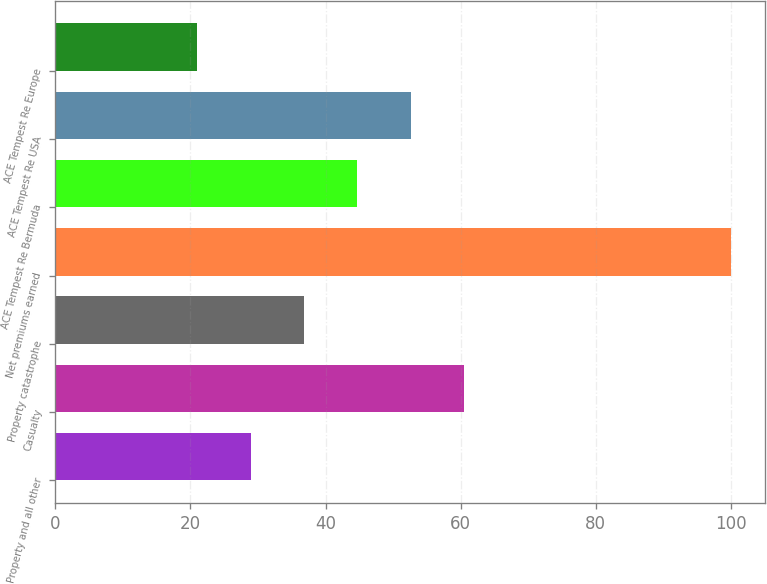<chart> <loc_0><loc_0><loc_500><loc_500><bar_chart><fcel>Property and all other<fcel>Casualty<fcel>Property catastrophe<fcel>Net premiums earned<fcel>ACE Tempest Re Bermuda<fcel>ACE Tempest Re USA<fcel>ACE Tempest Re Europe<nl><fcel>28.9<fcel>60.5<fcel>36.8<fcel>100<fcel>44.7<fcel>52.6<fcel>21<nl></chart> 